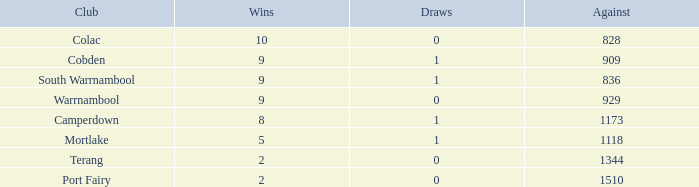What is the aggregate of losses for against values over 1510? None. 